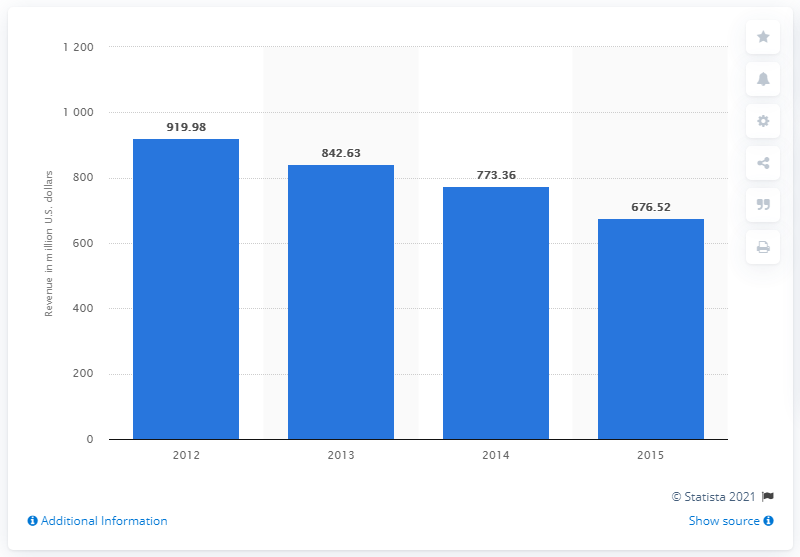Give some essential details in this illustration. In 2013, Fitness First UK's revenue was 842.63. 